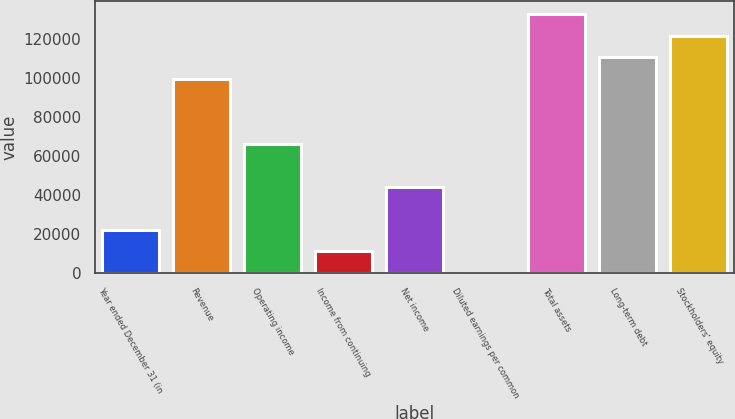<chart> <loc_0><loc_0><loc_500><loc_500><bar_chart><fcel>Year ended December 31 (in<fcel>Revenue<fcel>Operating income<fcel>Income from continuing<fcel>Net income<fcel>Diluted earnings per common<fcel>Total assets<fcel>Long-term debt<fcel>Stockholders' equity<nl><fcel>22081.6<fcel>99364.6<fcel>66243.3<fcel>11041.1<fcel>44162.4<fcel>0.7<fcel>132486<fcel>110405<fcel>121445<nl></chart> 